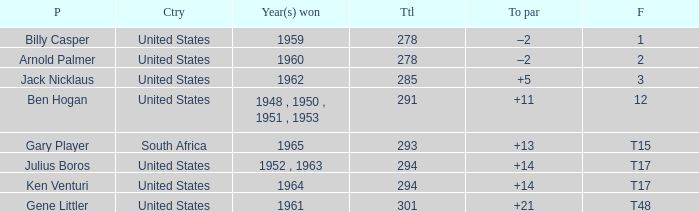What is Year(s) Won, when Total is less than 285? 1959, 1960. 